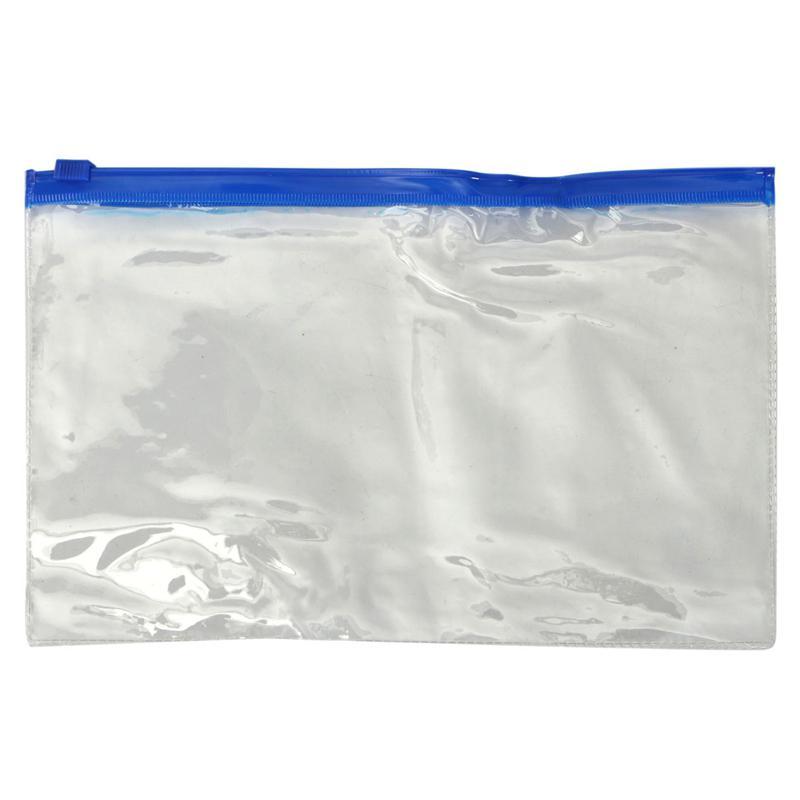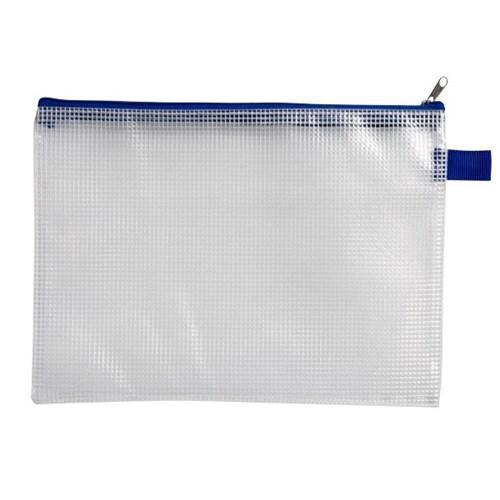The first image is the image on the left, the second image is the image on the right. Given the left and right images, does the statement "There are 2 pencil cases, each with 1 zipper." hold true? Answer yes or no. Yes. The first image is the image on the left, the second image is the image on the right. Given the left and right images, does the statement "One clear pencil case has only a blue zipper on top, and one pencil case has at least a pink zipper across the top." hold true? Answer yes or no. No. 